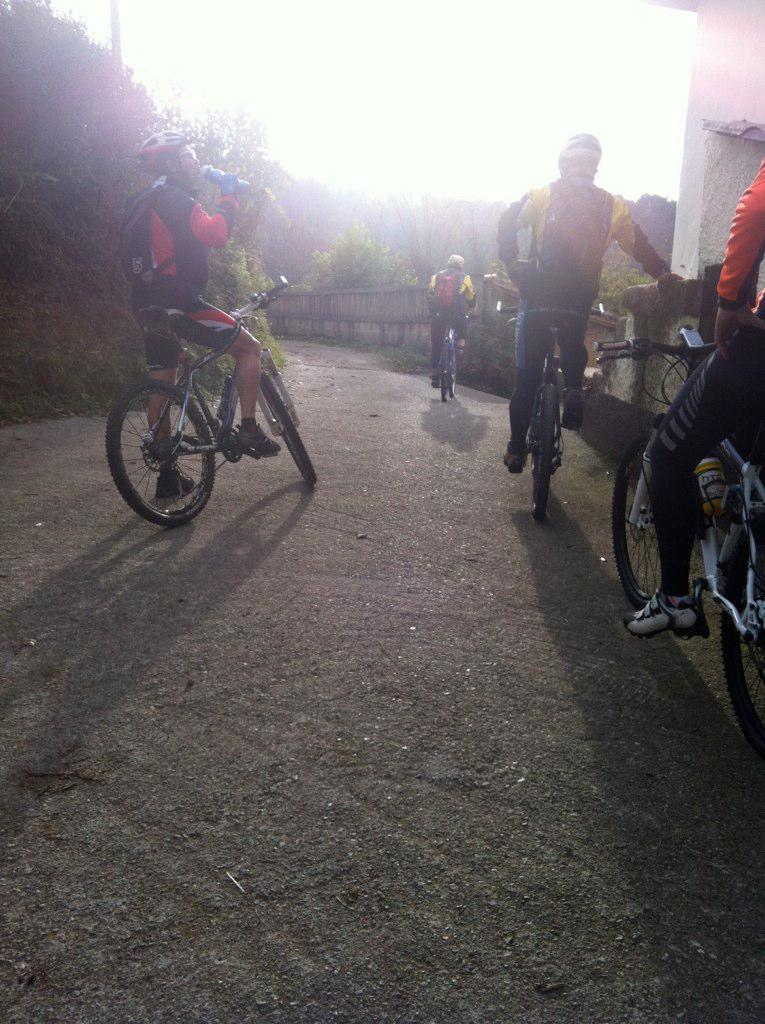What are the people in the image doing? The people in the image are riding bicycles. What type of natural elements can be seen in the image? There are trees and a mountain in the image. What is the condition of the sky in the image? The sky is clear in the image. What color is the birthday balloon held by the carpenter in the image? There is no birthday balloon or carpenter present in the image. 